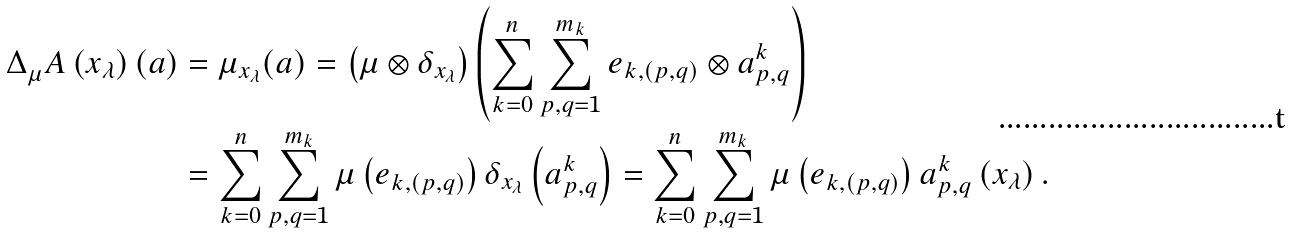Convert formula to latex. <formula><loc_0><loc_0><loc_500><loc_500>\Delta _ { \mu } ^ { \ } A \left ( x _ { \lambda } \right ) ( a ) & = \mu _ { x _ { \lambda } } ( a ) = \left ( \mu \otimes \delta _ { x _ { \lambda } } \right ) \left ( \sum _ { k = 0 } ^ { n } \sum _ { p , q = 1 } ^ { m _ { k } } e _ { k , ( p , q ) } \otimes a ^ { k } _ { p , q } \right ) \\ & = \sum _ { k = 0 } ^ { n } \sum _ { p , q = 1 } ^ { m _ { k } } \mu \left ( e _ { k , ( p , q ) } \right ) \delta _ { x _ { \lambda } } \left ( a ^ { k } _ { p , q } \right ) = \sum _ { k = 0 } ^ { n } \sum _ { p , q = 1 } ^ { m _ { k } } \mu \left ( e _ { k , ( p , q ) } \right ) a ^ { k } _ { p , q } \left ( x _ { \lambda } \right ) .</formula> 